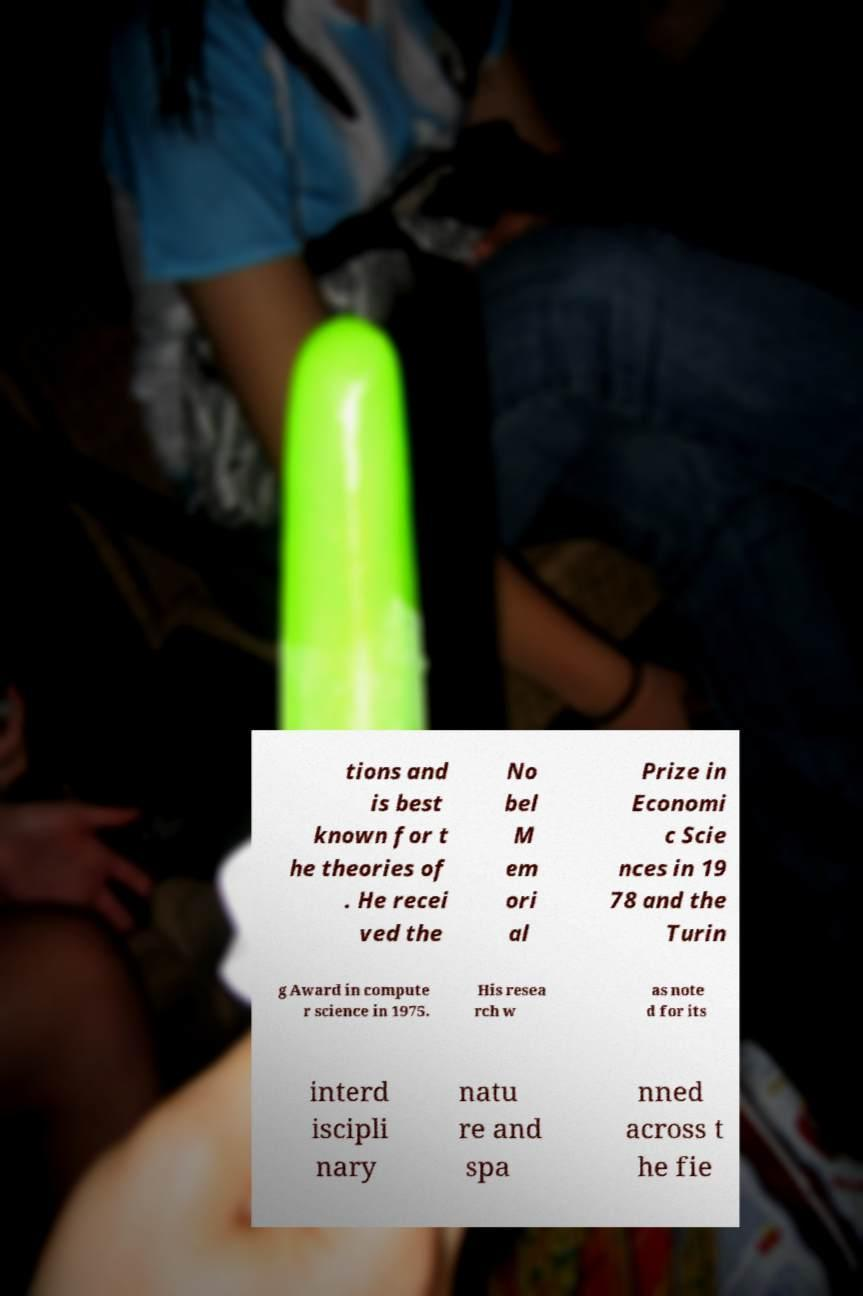Can you read and provide the text displayed in the image?This photo seems to have some interesting text. Can you extract and type it out for me? tions and is best known for t he theories of . He recei ved the No bel M em ori al Prize in Economi c Scie nces in 19 78 and the Turin g Award in compute r science in 1975. His resea rch w as note d for its interd iscipli nary natu re and spa nned across t he fie 